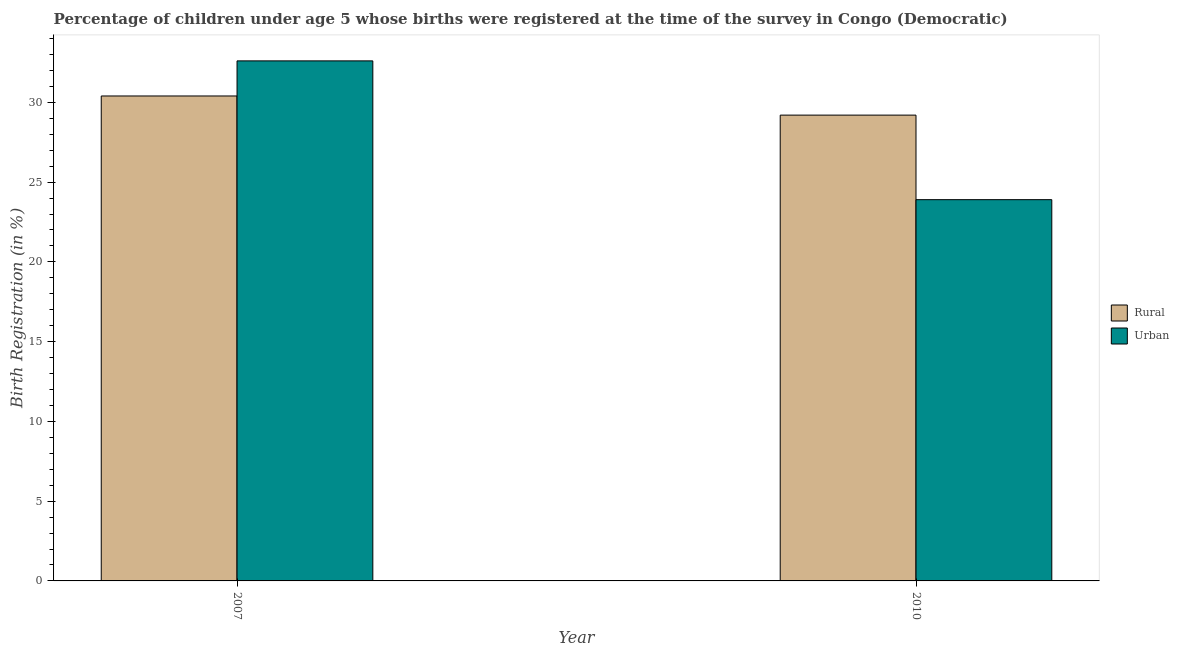How many bars are there on the 1st tick from the right?
Keep it short and to the point. 2. What is the label of the 2nd group of bars from the left?
Ensure brevity in your answer.  2010. What is the rural birth registration in 2007?
Give a very brief answer. 30.4. Across all years, what is the maximum urban birth registration?
Your response must be concise. 32.6. Across all years, what is the minimum rural birth registration?
Your answer should be compact. 29.2. In which year was the rural birth registration maximum?
Ensure brevity in your answer.  2007. What is the total urban birth registration in the graph?
Offer a terse response. 56.5. What is the difference between the urban birth registration in 2007 and that in 2010?
Your answer should be compact. 8.7. What is the difference between the rural birth registration in 2010 and the urban birth registration in 2007?
Your response must be concise. -1.2. What is the average rural birth registration per year?
Your response must be concise. 29.8. In the year 2010, what is the difference between the urban birth registration and rural birth registration?
Your response must be concise. 0. What is the ratio of the rural birth registration in 2007 to that in 2010?
Your response must be concise. 1.04. Is the urban birth registration in 2007 less than that in 2010?
Offer a very short reply. No. In how many years, is the urban birth registration greater than the average urban birth registration taken over all years?
Give a very brief answer. 1. What does the 1st bar from the left in 2007 represents?
Offer a terse response. Rural. What does the 2nd bar from the right in 2010 represents?
Give a very brief answer. Rural. How many bars are there?
Provide a short and direct response. 4. Are all the bars in the graph horizontal?
Make the answer very short. No. What is the difference between two consecutive major ticks on the Y-axis?
Your answer should be compact. 5. What is the title of the graph?
Provide a short and direct response. Percentage of children under age 5 whose births were registered at the time of the survey in Congo (Democratic). Does "Nitrous oxide" appear as one of the legend labels in the graph?
Provide a succinct answer. No. What is the label or title of the X-axis?
Give a very brief answer. Year. What is the label or title of the Y-axis?
Offer a terse response. Birth Registration (in %). What is the Birth Registration (in %) in Rural in 2007?
Make the answer very short. 30.4. What is the Birth Registration (in %) in Urban in 2007?
Give a very brief answer. 32.6. What is the Birth Registration (in %) of Rural in 2010?
Provide a succinct answer. 29.2. What is the Birth Registration (in %) in Urban in 2010?
Ensure brevity in your answer.  23.9. Across all years, what is the maximum Birth Registration (in %) in Rural?
Keep it short and to the point. 30.4. Across all years, what is the maximum Birth Registration (in %) of Urban?
Make the answer very short. 32.6. Across all years, what is the minimum Birth Registration (in %) in Rural?
Your answer should be compact. 29.2. Across all years, what is the minimum Birth Registration (in %) in Urban?
Make the answer very short. 23.9. What is the total Birth Registration (in %) in Rural in the graph?
Provide a short and direct response. 59.6. What is the total Birth Registration (in %) of Urban in the graph?
Make the answer very short. 56.5. What is the average Birth Registration (in %) in Rural per year?
Your answer should be compact. 29.8. What is the average Birth Registration (in %) of Urban per year?
Offer a terse response. 28.25. In the year 2007, what is the difference between the Birth Registration (in %) of Rural and Birth Registration (in %) of Urban?
Ensure brevity in your answer.  -2.2. What is the ratio of the Birth Registration (in %) in Rural in 2007 to that in 2010?
Provide a short and direct response. 1.04. What is the ratio of the Birth Registration (in %) of Urban in 2007 to that in 2010?
Your answer should be very brief. 1.36. What is the difference between the highest and the second highest Birth Registration (in %) in Urban?
Ensure brevity in your answer.  8.7. What is the difference between the highest and the lowest Birth Registration (in %) in Urban?
Provide a succinct answer. 8.7. 